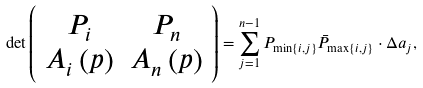<formula> <loc_0><loc_0><loc_500><loc_500>\det \left ( \begin{array} { c c } P _ { i } & P _ { n } \\ A _ { i } \left ( p \right ) & A _ { n } \left ( p \right ) \end{array} \right ) = \sum _ { j = 1 } ^ { n - 1 } P _ { \min \left \{ i , j \right \} } \bar { P } _ { \max \left \{ i , j \right \} } \cdot \Delta a _ { j } ,</formula> 